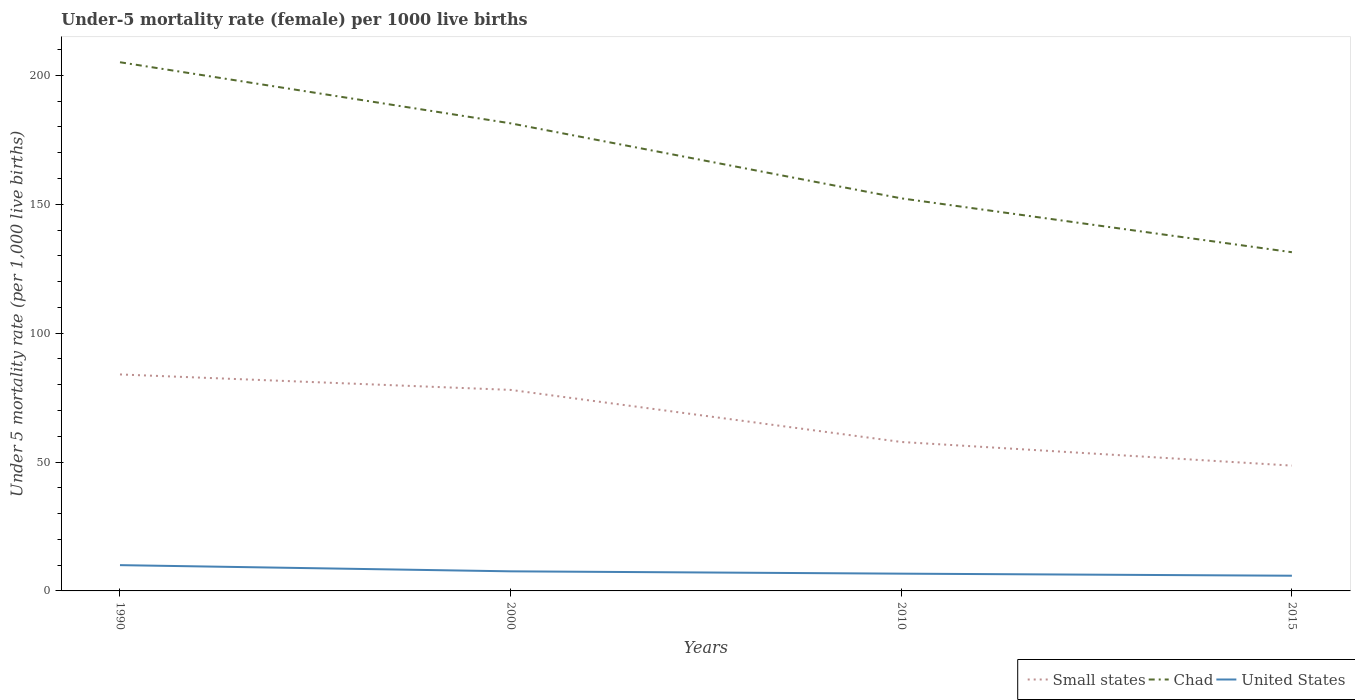How many different coloured lines are there?
Your answer should be very brief. 3. Does the line corresponding to United States intersect with the line corresponding to Chad?
Ensure brevity in your answer.  No. Across all years, what is the maximum under-five mortality rate in Small states?
Your answer should be compact. 48.62. In which year was the under-five mortality rate in Small states maximum?
Make the answer very short. 2015. What is the total under-five mortality rate in Small states in the graph?
Provide a succinct answer. 20.2. What is the difference between the highest and the second highest under-five mortality rate in United States?
Provide a short and direct response. 4.1. What is the difference between the highest and the lowest under-five mortality rate in Small states?
Offer a very short reply. 2. What is the difference between two consecutive major ticks on the Y-axis?
Your answer should be compact. 50. Are the values on the major ticks of Y-axis written in scientific E-notation?
Your answer should be very brief. No. Does the graph contain any zero values?
Keep it short and to the point. No. How are the legend labels stacked?
Keep it short and to the point. Horizontal. What is the title of the graph?
Offer a terse response. Under-5 mortality rate (female) per 1000 live births. What is the label or title of the X-axis?
Your answer should be very brief. Years. What is the label or title of the Y-axis?
Your answer should be compact. Under 5 mortality rate (per 1,0 live births). What is the Under 5 mortality rate (per 1,000 live births) in Small states in 1990?
Offer a very short reply. 83.98. What is the Under 5 mortality rate (per 1,000 live births) in Chad in 1990?
Ensure brevity in your answer.  205.1. What is the Under 5 mortality rate (per 1,000 live births) of Small states in 2000?
Your answer should be very brief. 77.99. What is the Under 5 mortality rate (per 1,000 live births) in Chad in 2000?
Your answer should be compact. 181.4. What is the Under 5 mortality rate (per 1,000 live births) in United States in 2000?
Keep it short and to the point. 7.6. What is the Under 5 mortality rate (per 1,000 live births) of Small states in 2010?
Give a very brief answer. 57.78. What is the Under 5 mortality rate (per 1,000 live births) of Chad in 2010?
Provide a succinct answer. 152.3. What is the Under 5 mortality rate (per 1,000 live births) of United States in 2010?
Offer a very short reply. 6.7. What is the Under 5 mortality rate (per 1,000 live births) of Small states in 2015?
Your response must be concise. 48.62. What is the Under 5 mortality rate (per 1,000 live births) of Chad in 2015?
Provide a succinct answer. 131.4. Across all years, what is the maximum Under 5 mortality rate (per 1,000 live births) of Small states?
Give a very brief answer. 83.98. Across all years, what is the maximum Under 5 mortality rate (per 1,000 live births) of Chad?
Your answer should be very brief. 205.1. Across all years, what is the minimum Under 5 mortality rate (per 1,000 live births) in Small states?
Your response must be concise. 48.62. Across all years, what is the minimum Under 5 mortality rate (per 1,000 live births) in Chad?
Provide a succinct answer. 131.4. Across all years, what is the minimum Under 5 mortality rate (per 1,000 live births) of United States?
Offer a terse response. 5.9. What is the total Under 5 mortality rate (per 1,000 live births) of Small states in the graph?
Your answer should be compact. 268.37. What is the total Under 5 mortality rate (per 1,000 live births) in Chad in the graph?
Keep it short and to the point. 670.2. What is the total Under 5 mortality rate (per 1,000 live births) in United States in the graph?
Keep it short and to the point. 30.2. What is the difference between the Under 5 mortality rate (per 1,000 live births) of Small states in 1990 and that in 2000?
Offer a very short reply. 6. What is the difference between the Under 5 mortality rate (per 1,000 live births) of Chad in 1990 and that in 2000?
Ensure brevity in your answer.  23.7. What is the difference between the Under 5 mortality rate (per 1,000 live births) in Small states in 1990 and that in 2010?
Your answer should be compact. 26.2. What is the difference between the Under 5 mortality rate (per 1,000 live births) in Chad in 1990 and that in 2010?
Your answer should be very brief. 52.8. What is the difference between the Under 5 mortality rate (per 1,000 live births) of United States in 1990 and that in 2010?
Your answer should be compact. 3.3. What is the difference between the Under 5 mortality rate (per 1,000 live births) in Small states in 1990 and that in 2015?
Make the answer very short. 35.37. What is the difference between the Under 5 mortality rate (per 1,000 live births) of Chad in 1990 and that in 2015?
Your answer should be very brief. 73.7. What is the difference between the Under 5 mortality rate (per 1,000 live births) of United States in 1990 and that in 2015?
Your answer should be compact. 4.1. What is the difference between the Under 5 mortality rate (per 1,000 live births) of Small states in 2000 and that in 2010?
Your answer should be compact. 20.2. What is the difference between the Under 5 mortality rate (per 1,000 live births) of Chad in 2000 and that in 2010?
Make the answer very short. 29.1. What is the difference between the Under 5 mortality rate (per 1,000 live births) of Small states in 2000 and that in 2015?
Your answer should be compact. 29.37. What is the difference between the Under 5 mortality rate (per 1,000 live births) in Chad in 2000 and that in 2015?
Make the answer very short. 50. What is the difference between the Under 5 mortality rate (per 1,000 live births) in United States in 2000 and that in 2015?
Your answer should be compact. 1.7. What is the difference between the Under 5 mortality rate (per 1,000 live births) of Small states in 2010 and that in 2015?
Provide a succinct answer. 9.17. What is the difference between the Under 5 mortality rate (per 1,000 live births) in Chad in 2010 and that in 2015?
Provide a short and direct response. 20.9. What is the difference between the Under 5 mortality rate (per 1,000 live births) in United States in 2010 and that in 2015?
Keep it short and to the point. 0.8. What is the difference between the Under 5 mortality rate (per 1,000 live births) of Small states in 1990 and the Under 5 mortality rate (per 1,000 live births) of Chad in 2000?
Keep it short and to the point. -97.42. What is the difference between the Under 5 mortality rate (per 1,000 live births) in Small states in 1990 and the Under 5 mortality rate (per 1,000 live births) in United States in 2000?
Your answer should be very brief. 76.38. What is the difference between the Under 5 mortality rate (per 1,000 live births) of Chad in 1990 and the Under 5 mortality rate (per 1,000 live births) of United States in 2000?
Your answer should be very brief. 197.5. What is the difference between the Under 5 mortality rate (per 1,000 live births) of Small states in 1990 and the Under 5 mortality rate (per 1,000 live births) of Chad in 2010?
Offer a very short reply. -68.32. What is the difference between the Under 5 mortality rate (per 1,000 live births) of Small states in 1990 and the Under 5 mortality rate (per 1,000 live births) of United States in 2010?
Offer a terse response. 77.28. What is the difference between the Under 5 mortality rate (per 1,000 live births) in Chad in 1990 and the Under 5 mortality rate (per 1,000 live births) in United States in 2010?
Your response must be concise. 198.4. What is the difference between the Under 5 mortality rate (per 1,000 live births) of Small states in 1990 and the Under 5 mortality rate (per 1,000 live births) of Chad in 2015?
Your answer should be very brief. -47.42. What is the difference between the Under 5 mortality rate (per 1,000 live births) of Small states in 1990 and the Under 5 mortality rate (per 1,000 live births) of United States in 2015?
Your response must be concise. 78.08. What is the difference between the Under 5 mortality rate (per 1,000 live births) in Chad in 1990 and the Under 5 mortality rate (per 1,000 live births) in United States in 2015?
Keep it short and to the point. 199.2. What is the difference between the Under 5 mortality rate (per 1,000 live births) of Small states in 2000 and the Under 5 mortality rate (per 1,000 live births) of Chad in 2010?
Provide a short and direct response. -74.31. What is the difference between the Under 5 mortality rate (per 1,000 live births) in Small states in 2000 and the Under 5 mortality rate (per 1,000 live births) in United States in 2010?
Provide a short and direct response. 71.29. What is the difference between the Under 5 mortality rate (per 1,000 live births) in Chad in 2000 and the Under 5 mortality rate (per 1,000 live births) in United States in 2010?
Your answer should be compact. 174.7. What is the difference between the Under 5 mortality rate (per 1,000 live births) of Small states in 2000 and the Under 5 mortality rate (per 1,000 live births) of Chad in 2015?
Your answer should be very brief. -53.41. What is the difference between the Under 5 mortality rate (per 1,000 live births) of Small states in 2000 and the Under 5 mortality rate (per 1,000 live births) of United States in 2015?
Give a very brief answer. 72.09. What is the difference between the Under 5 mortality rate (per 1,000 live births) in Chad in 2000 and the Under 5 mortality rate (per 1,000 live births) in United States in 2015?
Your answer should be very brief. 175.5. What is the difference between the Under 5 mortality rate (per 1,000 live births) of Small states in 2010 and the Under 5 mortality rate (per 1,000 live births) of Chad in 2015?
Your answer should be compact. -73.62. What is the difference between the Under 5 mortality rate (per 1,000 live births) of Small states in 2010 and the Under 5 mortality rate (per 1,000 live births) of United States in 2015?
Offer a terse response. 51.88. What is the difference between the Under 5 mortality rate (per 1,000 live births) in Chad in 2010 and the Under 5 mortality rate (per 1,000 live births) in United States in 2015?
Keep it short and to the point. 146.4. What is the average Under 5 mortality rate (per 1,000 live births) in Small states per year?
Provide a succinct answer. 67.09. What is the average Under 5 mortality rate (per 1,000 live births) of Chad per year?
Your answer should be very brief. 167.55. What is the average Under 5 mortality rate (per 1,000 live births) of United States per year?
Your answer should be compact. 7.55. In the year 1990, what is the difference between the Under 5 mortality rate (per 1,000 live births) of Small states and Under 5 mortality rate (per 1,000 live births) of Chad?
Provide a succinct answer. -121.12. In the year 1990, what is the difference between the Under 5 mortality rate (per 1,000 live births) of Small states and Under 5 mortality rate (per 1,000 live births) of United States?
Your response must be concise. 73.98. In the year 1990, what is the difference between the Under 5 mortality rate (per 1,000 live births) in Chad and Under 5 mortality rate (per 1,000 live births) in United States?
Provide a succinct answer. 195.1. In the year 2000, what is the difference between the Under 5 mortality rate (per 1,000 live births) in Small states and Under 5 mortality rate (per 1,000 live births) in Chad?
Offer a very short reply. -103.41. In the year 2000, what is the difference between the Under 5 mortality rate (per 1,000 live births) of Small states and Under 5 mortality rate (per 1,000 live births) of United States?
Make the answer very short. 70.39. In the year 2000, what is the difference between the Under 5 mortality rate (per 1,000 live births) of Chad and Under 5 mortality rate (per 1,000 live births) of United States?
Keep it short and to the point. 173.8. In the year 2010, what is the difference between the Under 5 mortality rate (per 1,000 live births) in Small states and Under 5 mortality rate (per 1,000 live births) in Chad?
Your response must be concise. -94.52. In the year 2010, what is the difference between the Under 5 mortality rate (per 1,000 live births) of Small states and Under 5 mortality rate (per 1,000 live births) of United States?
Offer a very short reply. 51.08. In the year 2010, what is the difference between the Under 5 mortality rate (per 1,000 live births) in Chad and Under 5 mortality rate (per 1,000 live births) in United States?
Offer a terse response. 145.6. In the year 2015, what is the difference between the Under 5 mortality rate (per 1,000 live births) in Small states and Under 5 mortality rate (per 1,000 live births) in Chad?
Keep it short and to the point. -82.78. In the year 2015, what is the difference between the Under 5 mortality rate (per 1,000 live births) in Small states and Under 5 mortality rate (per 1,000 live births) in United States?
Provide a short and direct response. 42.72. In the year 2015, what is the difference between the Under 5 mortality rate (per 1,000 live births) in Chad and Under 5 mortality rate (per 1,000 live births) in United States?
Your answer should be compact. 125.5. What is the ratio of the Under 5 mortality rate (per 1,000 live births) of Small states in 1990 to that in 2000?
Provide a succinct answer. 1.08. What is the ratio of the Under 5 mortality rate (per 1,000 live births) in Chad in 1990 to that in 2000?
Provide a short and direct response. 1.13. What is the ratio of the Under 5 mortality rate (per 1,000 live births) of United States in 1990 to that in 2000?
Give a very brief answer. 1.32. What is the ratio of the Under 5 mortality rate (per 1,000 live births) of Small states in 1990 to that in 2010?
Your response must be concise. 1.45. What is the ratio of the Under 5 mortality rate (per 1,000 live births) in Chad in 1990 to that in 2010?
Provide a short and direct response. 1.35. What is the ratio of the Under 5 mortality rate (per 1,000 live births) in United States in 1990 to that in 2010?
Your answer should be compact. 1.49. What is the ratio of the Under 5 mortality rate (per 1,000 live births) of Small states in 1990 to that in 2015?
Ensure brevity in your answer.  1.73. What is the ratio of the Under 5 mortality rate (per 1,000 live births) in Chad in 1990 to that in 2015?
Make the answer very short. 1.56. What is the ratio of the Under 5 mortality rate (per 1,000 live births) in United States in 1990 to that in 2015?
Give a very brief answer. 1.69. What is the ratio of the Under 5 mortality rate (per 1,000 live births) of Small states in 2000 to that in 2010?
Your answer should be compact. 1.35. What is the ratio of the Under 5 mortality rate (per 1,000 live births) in Chad in 2000 to that in 2010?
Keep it short and to the point. 1.19. What is the ratio of the Under 5 mortality rate (per 1,000 live births) of United States in 2000 to that in 2010?
Ensure brevity in your answer.  1.13. What is the ratio of the Under 5 mortality rate (per 1,000 live births) of Small states in 2000 to that in 2015?
Your response must be concise. 1.6. What is the ratio of the Under 5 mortality rate (per 1,000 live births) of Chad in 2000 to that in 2015?
Ensure brevity in your answer.  1.38. What is the ratio of the Under 5 mortality rate (per 1,000 live births) of United States in 2000 to that in 2015?
Provide a short and direct response. 1.29. What is the ratio of the Under 5 mortality rate (per 1,000 live births) of Small states in 2010 to that in 2015?
Your response must be concise. 1.19. What is the ratio of the Under 5 mortality rate (per 1,000 live births) in Chad in 2010 to that in 2015?
Make the answer very short. 1.16. What is the ratio of the Under 5 mortality rate (per 1,000 live births) of United States in 2010 to that in 2015?
Keep it short and to the point. 1.14. What is the difference between the highest and the second highest Under 5 mortality rate (per 1,000 live births) of Small states?
Your response must be concise. 6. What is the difference between the highest and the second highest Under 5 mortality rate (per 1,000 live births) in Chad?
Your answer should be compact. 23.7. What is the difference between the highest and the second highest Under 5 mortality rate (per 1,000 live births) of United States?
Your response must be concise. 2.4. What is the difference between the highest and the lowest Under 5 mortality rate (per 1,000 live births) in Small states?
Your response must be concise. 35.37. What is the difference between the highest and the lowest Under 5 mortality rate (per 1,000 live births) in Chad?
Give a very brief answer. 73.7. What is the difference between the highest and the lowest Under 5 mortality rate (per 1,000 live births) of United States?
Give a very brief answer. 4.1. 